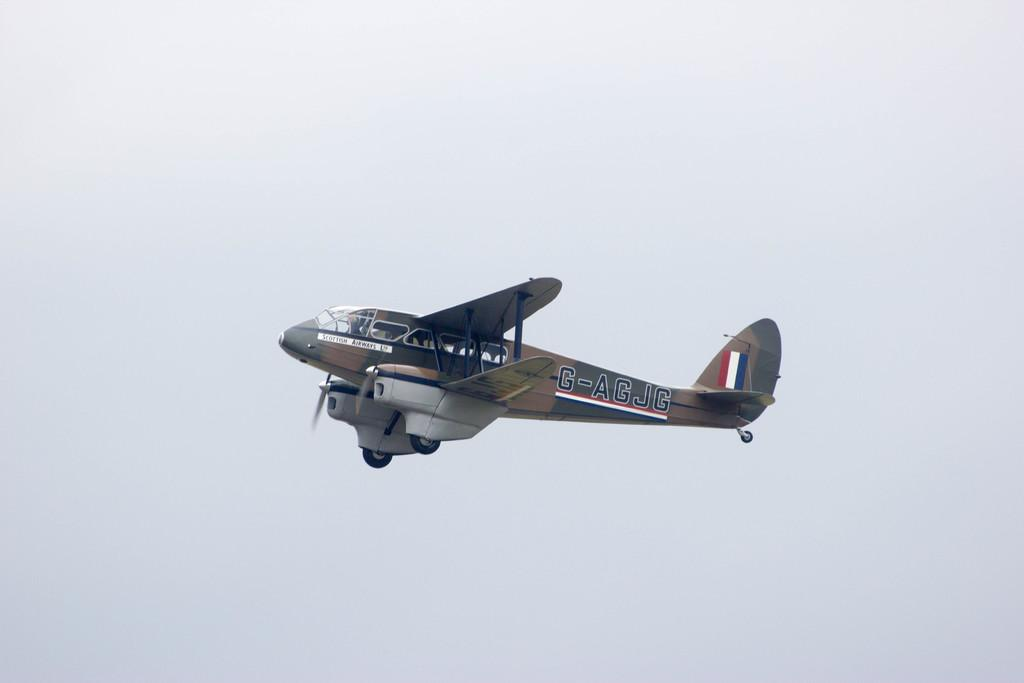What is the main subject of the image? The main subject of the image is an airplane. Where is the airplane located in the image? The airplane is in the sky. How would you describe the sky in the image? The sky appears cloudy. What type of station can be seen in the image? There is no station present in the image; it features an airplane in the sky. What unit of measurement is used to determine the airplane's altitude in the image? The image does not provide information about the airplane's altitude or the unit of measurement used. 